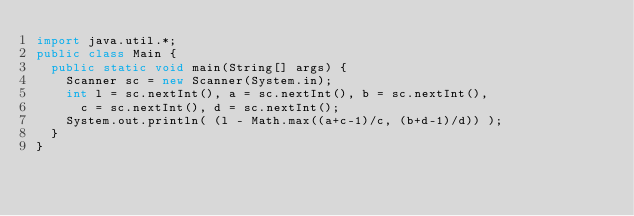Convert code to text. <code><loc_0><loc_0><loc_500><loc_500><_Java_>import java.util.*;
public class Main {
	public static void main(String[] args) {
		Scanner sc = new Scanner(System.in);
		int l = sc.nextInt(), a = sc.nextInt(), b = sc.nextInt(),
			c = sc.nextInt(), d = sc.nextInt();
		System.out.println( (l - Math.max((a+c-1)/c, (b+d-1)/d)) );
	}
}</code> 